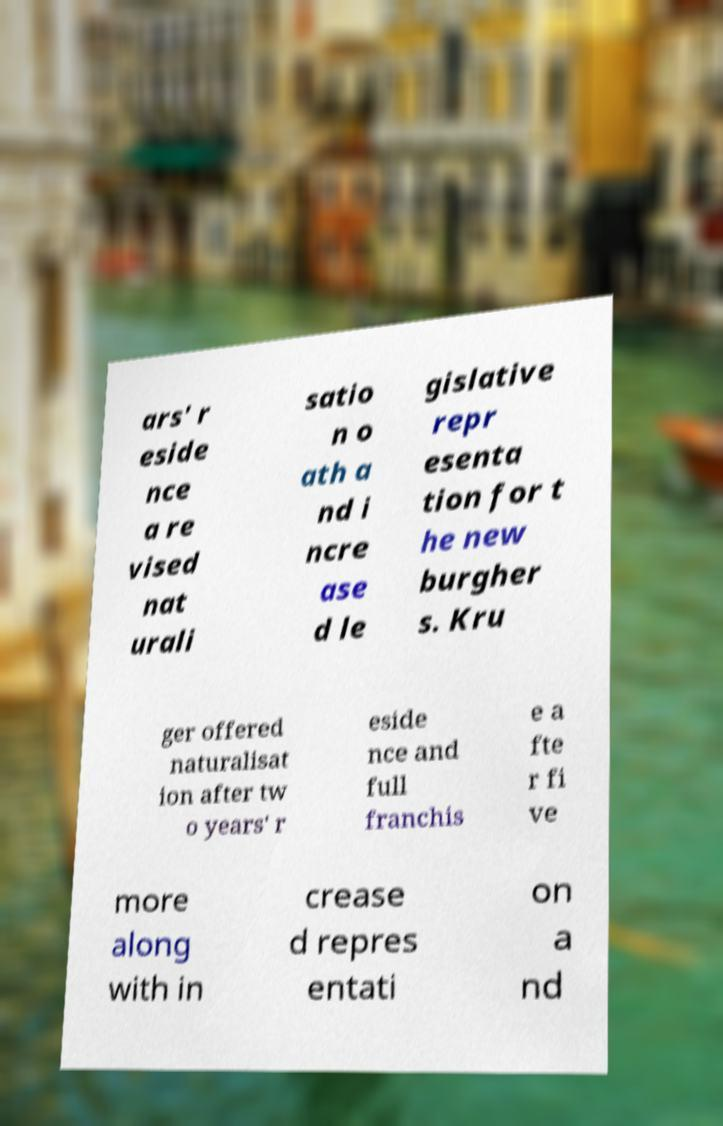Could you extract and type out the text from this image? ars' r eside nce a re vised nat urali satio n o ath a nd i ncre ase d le gislative repr esenta tion for t he new burgher s. Kru ger offered naturalisat ion after tw o years' r eside nce and full franchis e a fte r fi ve more along with in crease d repres entati on a nd 